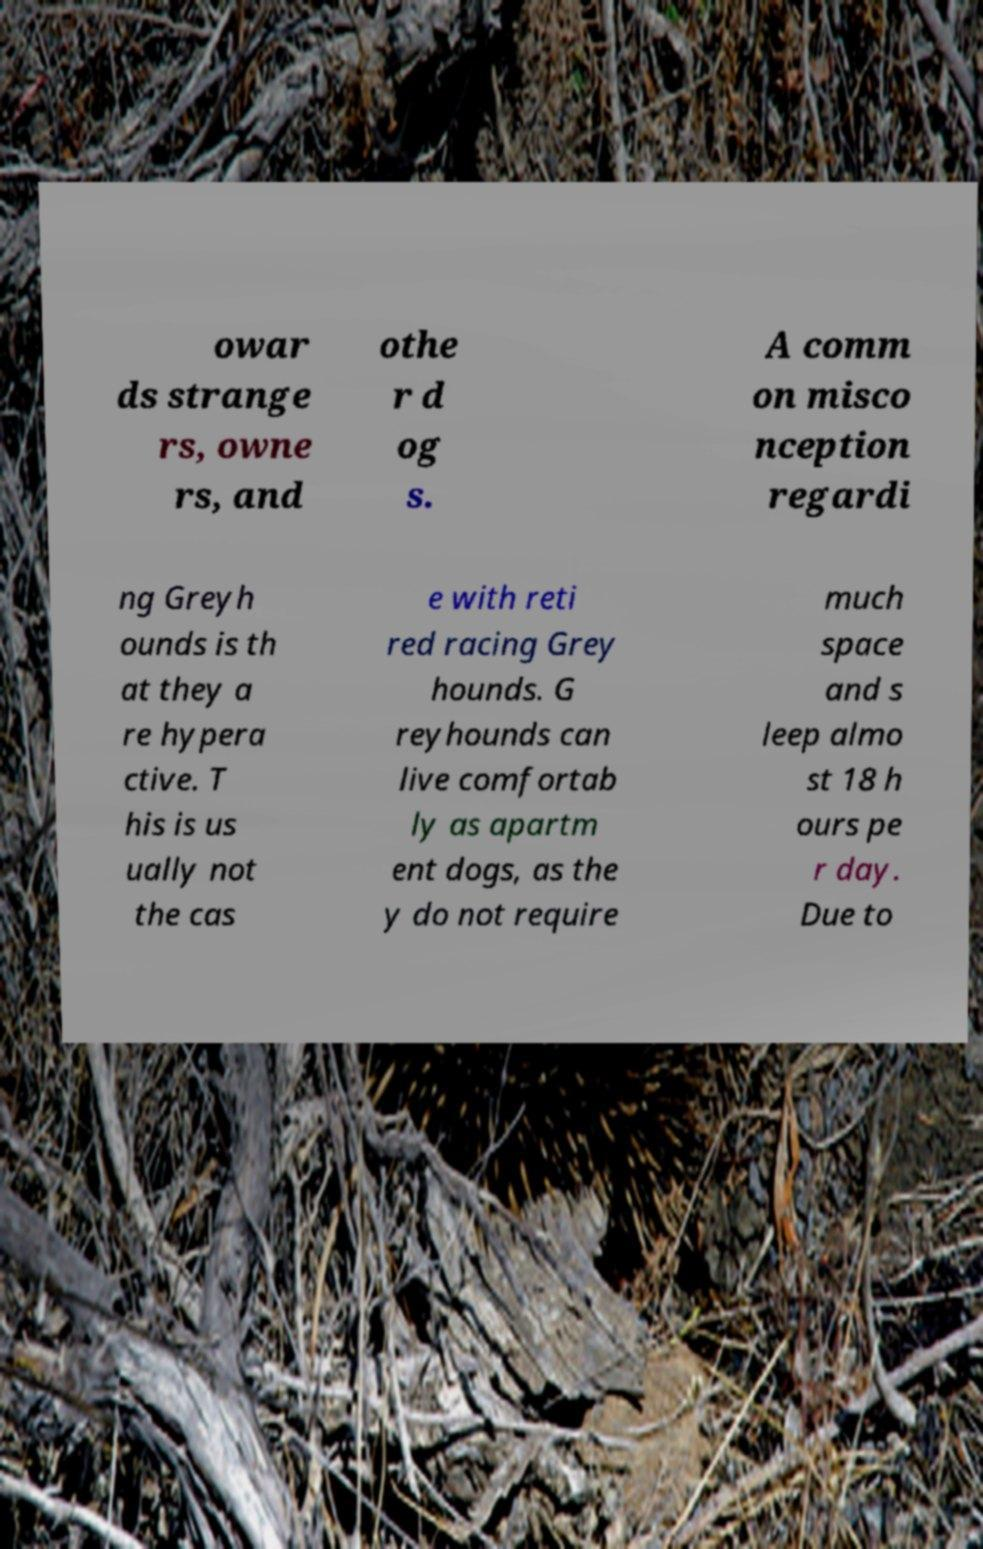Can you read and provide the text displayed in the image?This photo seems to have some interesting text. Can you extract and type it out for me? owar ds strange rs, owne rs, and othe r d og s. A comm on misco nception regardi ng Greyh ounds is th at they a re hypera ctive. T his is us ually not the cas e with reti red racing Grey hounds. G reyhounds can live comfortab ly as apartm ent dogs, as the y do not require much space and s leep almo st 18 h ours pe r day. Due to 